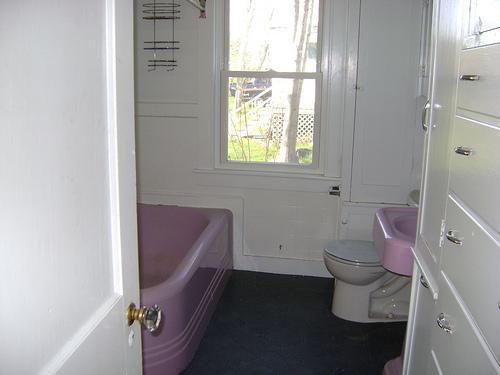How many sinks are in the bathroom?
Give a very brief answer. 1. 